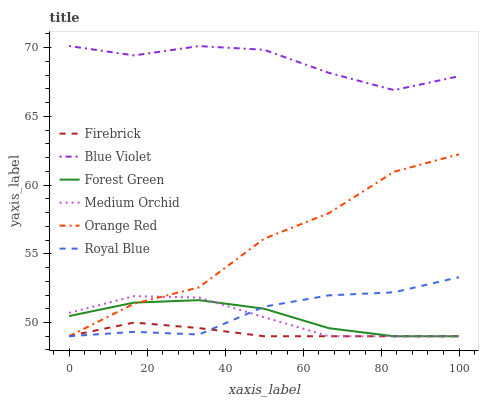Does Firebrick have the minimum area under the curve?
Answer yes or no. Yes. Does Blue Violet have the maximum area under the curve?
Answer yes or no. Yes. Does Medium Orchid have the minimum area under the curve?
Answer yes or no. No. Does Medium Orchid have the maximum area under the curve?
Answer yes or no. No. Is Firebrick the smoothest?
Answer yes or no. Yes. Is Orange Red the roughest?
Answer yes or no. Yes. Is Medium Orchid the smoothest?
Answer yes or no. No. Is Medium Orchid the roughest?
Answer yes or no. No. Does Blue Violet have the lowest value?
Answer yes or no. No. Does Blue Violet have the highest value?
Answer yes or no. Yes. Does Medium Orchid have the highest value?
Answer yes or no. No. Is Medium Orchid less than Blue Violet?
Answer yes or no. Yes. Is Blue Violet greater than Forest Green?
Answer yes or no. Yes. Does Medium Orchid intersect Orange Red?
Answer yes or no. Yes. Is Medium Orchid less than Orange Red?
Answer yes or no. No. Is Medium Orchid greater than Orange Red?
Answer yes or no. No. Does Medium Orchid intersect Blue Violet?
Answer yes or no. No. 